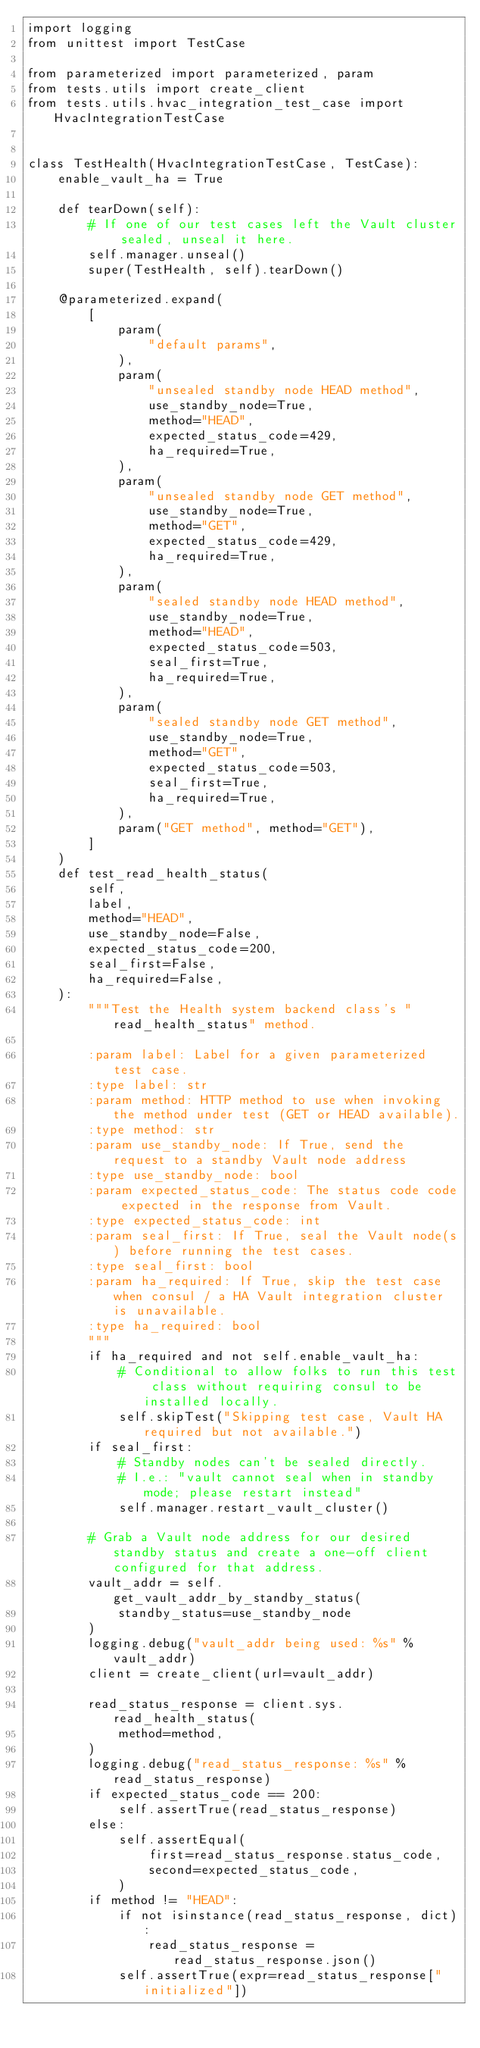Convert code to text. <code><loc_0><loc_0><loc_500><loc_500><_Python_>import logging
from unittest import TestCase

from parameterized import parameterized, param
from tests.utils import create_client
from tests.utils.hvac_integration_test_case import HvacIntegrationTestCase


class TestHealth(HvacIntegrationTestCase, TestCase):
    enable_vault_ha = True

    def tearDown(self):
        # If one of our test cases left the Vault cluster sealed, unseal it here.
        self.manager.unseal()
        super(TestHealth, self).tearDown()

    @parameterized.expand(
        [
            param(
                "default params",
            ),
            param(
                "unsealed standby node HEAD method",
                use_standby_node=True,
                method="HEAD",
                expected_status_code=429,
                ha_required=True,
            ),
            param(
                "unsealed standby node GET method",
                use_standby_node=True,
                method="GET",
                expected_status_code=429,
                ha_required=True,
            ),
            param(
                "sealed standby node HEAD method",
                use_standby_node=True,
                method="HEAD",
                expected_status_code=503,
                seal_first=True,
                ha_required=True,
            ),
            param(
                "sealed standby node GET method",
                use_standby_node=True,
                method="GET",
                expected_status_code=503,
                seal_first=True,
                ha_required=True,
            ),
            param("GET method", method="GET"),
        ]
    )
    def test_read_health_status(
        self,
        label,
        method="HEAD",
        use_standby_node=False,
        expected_status_code=200,
        seal_first=False,
        ha_required=False,
    ):
        """Test the Health system backend class's "read_health_status" method.

        :param label: Label for a given parameterized test case.
        :type label: str
        :param method: HTTP method to use when invoking the method under test (GET or HEAD available).
        :type method: str
        :param use_standby_node: If True, send the request to a standby Vault node address
        :type use_standby_node: bool
        :param expected_status_code: The status code code expected in the response from Vault.
        :type expected_status_code: int
        :param seal_first: If True, seal the Vault node(s) before running the test cases.
        :type seal_first: bool
        :param ha_required: If True, skip the test case when consul / a HA Vault integration cluster is unavailable.
        :type ha_required: bool
        """
        if ha_required and not self.enable_vault_ha:
            # Conditional to allow folks to run this test class without requiring consul to be installed locally.
            self.skipTest("Skipping test case, Vault HA required but not available.")
        if seal_first:
            # Standby nodes can't be sealed directly.
            # I.e.: "vault cannot seal when in standby mode; please restart instead"
            self.manager.restart_vault_cluster()

        # Grab a Vault node address for our desired standby status and create a one-off client configured for that address.
        vault_addr = self.get_vault_addr_by_standby_status(
            standby_status=use_standby_node
        )
        logging.debug("vault_addr being used: %s" % vault_addr)
        client = create_client(url=vault_addr)

        read_status_response = client.sys.read_health_status(
            method=method,
        )
        logging.debug("read_status_response: %s" % read_status_response)
        if expected_status_code == 200:
            self.assertTrue(read_status_response)
        else:
            self.assertEqual(
                first=read_status_response.status_code,
                second=expected_status_code,
            )
        if method != "HEAD":
            if not isinstance(read_status_response, dict):
                read_status_response = read_status_response.json()
            self.assertTrue(expr=read_status_response["initialized"])
</code> 